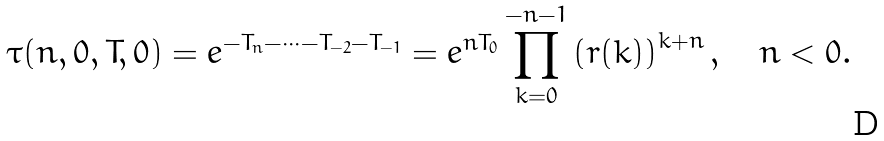Convert formula to latex. <formula><loc_0><loc_0><loc_500><loc_500>\tau ( n , { 0 } , { T } , { 0 } ) = e ^ { - T _ { n } - \cdots - T _ { - 2 } - T _ { - 1 } } = e ^ { n T _ { 0 } } \prod _ { k = 0 } ^ { - n - 1 } \left ( r ( k ) \right ) ^ { k + n } , \quad n < 0 .</formula> 